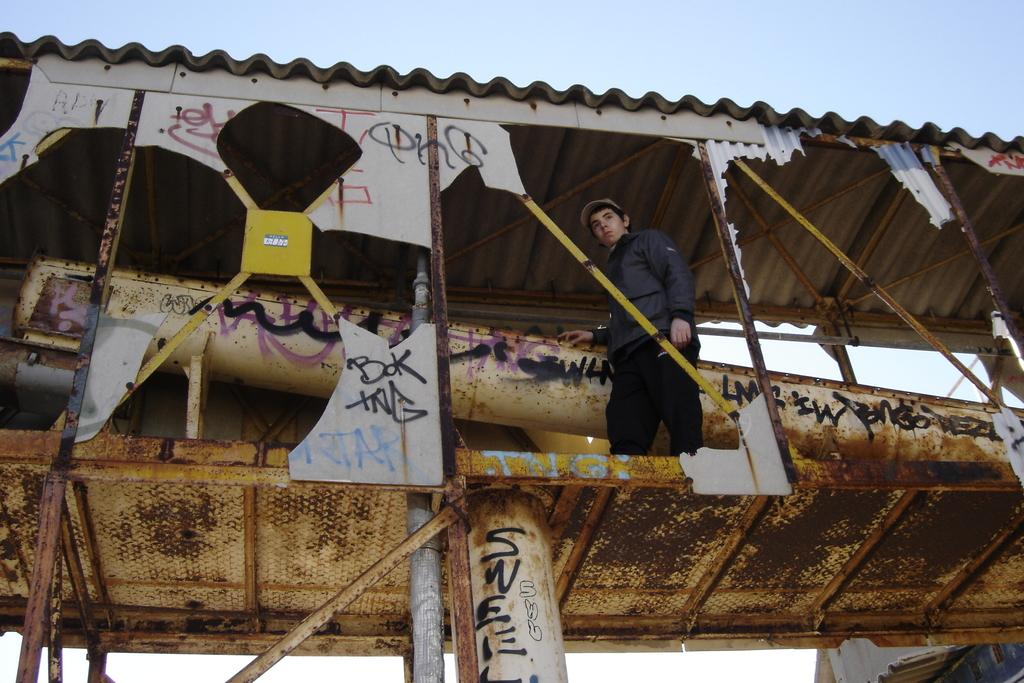Who or what is in the image? There is a person in the image. Where is the person located? The person is on a bridge. What is a feature of the bridge? There is a pillar associated with the bridge. What can be seen in the background of the image? The sky is visible in the background of the image. What type of wristwatch is the person wearing in the image? There is no wristwatch visible in the image. What type of servant is present in the image? There is no servant present in the image. 